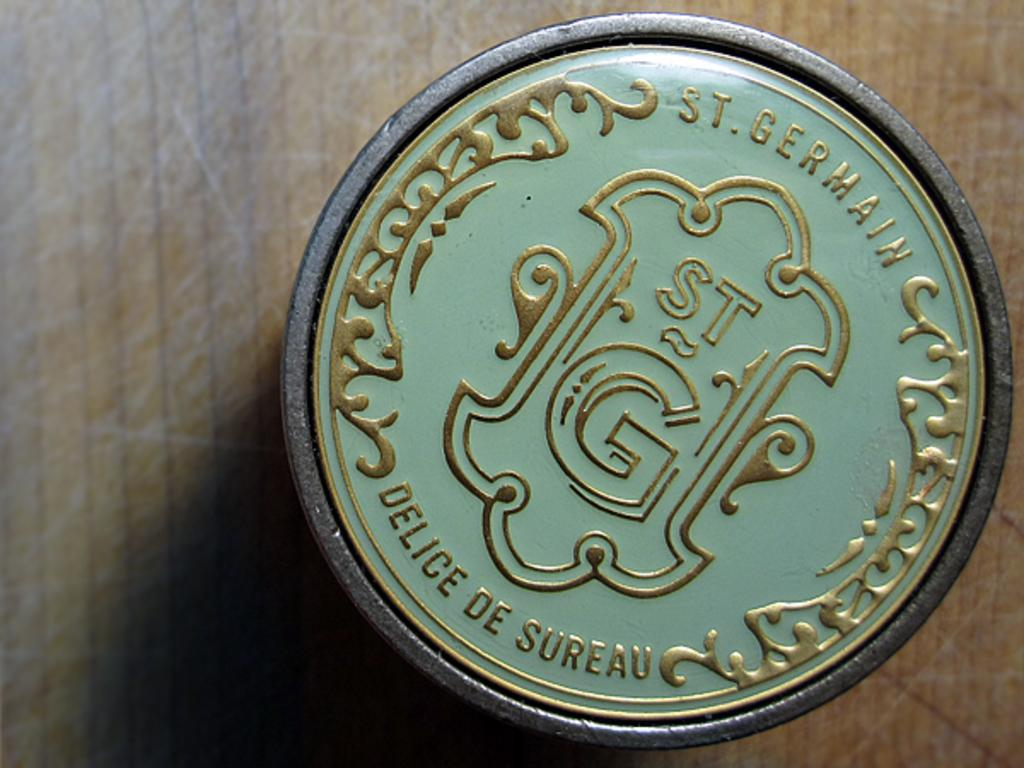<image>
Summarize the visual content of the image. A green background with gold designs and letters that read, "St. Germain" at the top. 